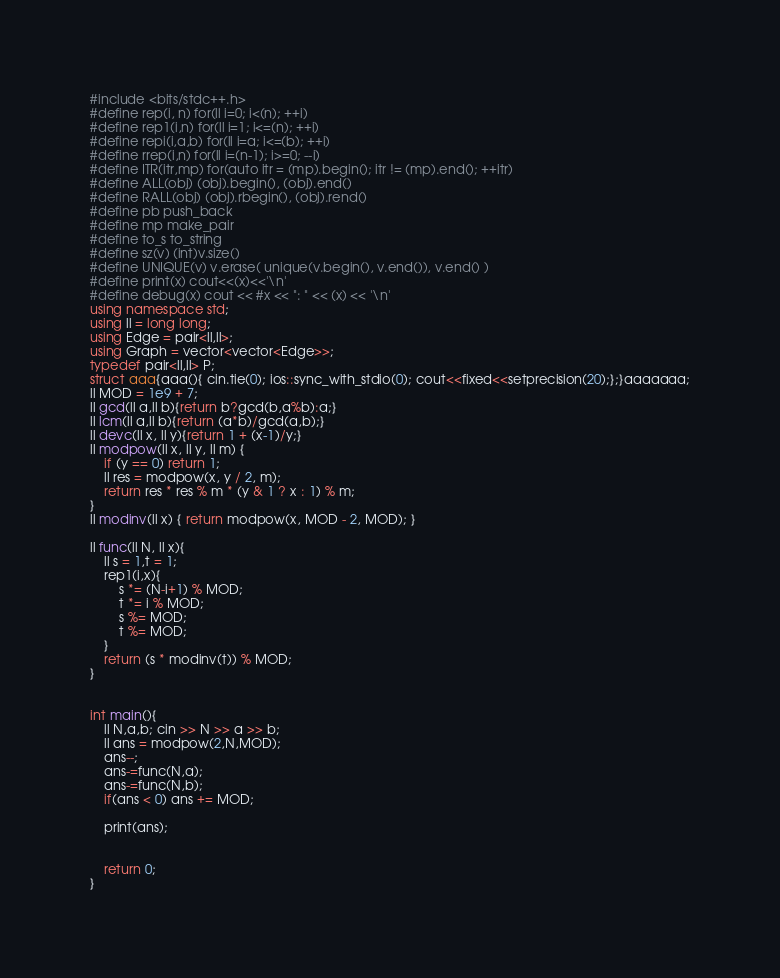Convert code to text. <code><loc_0><loc_0><loc_500><loc_500><_C++_>#include <bits/stdc++.h>
#define rep(i, n) for(ll i=0; i<(n); ++i)
#define rep1(i,n) for(ll i=1; i<=(n); ++i)
#define repi(i,a,b) for(ll i=a; i<=(b); ++i)
#define rrep(i,n) for(ll i=(n-1); i>=0; --i)
#define ITR(itr,mp) for(auto itr = (mp).begin(); itr != (mp).end(); ++itr)
#define ALL(obj) (obj).begin(), (obj).end()
#define RALL(obj) (obj).rbegin(), (obj).rend()
#define pb push_back
#define mp make_pair
#define to_s to_string
#define sz(v) (int)v.size()
#define UNIQUE(v) v.erase( unique(v.begin(), v.end()), v.end() )
#define print(x) cout<<(x)<<'\n'
#define debug(x) cout << #x << ": " << (x) << '\n'
using namespace std;
using ll = long long;
using Edge = pair<ll,ll>;
using Graph = vector<vector<Edge>>;
typedef pair<ll,ll> P;
struct aaa{aaa(){ cin.tie(0); ios::sync_with_stdio(0); cout<<fixed<<setprecision(20);};}aaaaaaa;
ll MOD = 1e9 + 7;
ll gcd(ll a,ll b){return b?gcd(b,a%b):a;}
ll lcm(ll a,ll b){return (a*b)/gcd(a,b);}
ll devc(ll x, ll y){return 1 + (x-1)/y;}
ll modpow(ll x, ll y, ll m) {
    if (y == 0) return 1;
    ll res = modpow(x, y / 2, m);
    return res * res % m * (y & 1 ? x : 1) % m;
}
ll modinv(ll x) { return modpow(x, MOD - 2, MOD); }

ll func(ll N, ll x){
    ll s = 1,t = 1;
    rep1(i,x){
        s *= (N-i+1) % MOD;
        t *= i % MOD;
        s %= MOD;
        t %= MOD;
    }
    return (s * modinv(t)) % MOD;
}


int main(){
    ll N,a,b; cin >> N >> a >> b;
    ll ans = modpow(2,N,MOD);
    ans--;
    ans-=func(N,a);
    ans-=func(N,b);
    if(ans < 0) ans += MOD;
    
    print(ans);
    
    
    return 0;
}</code> 